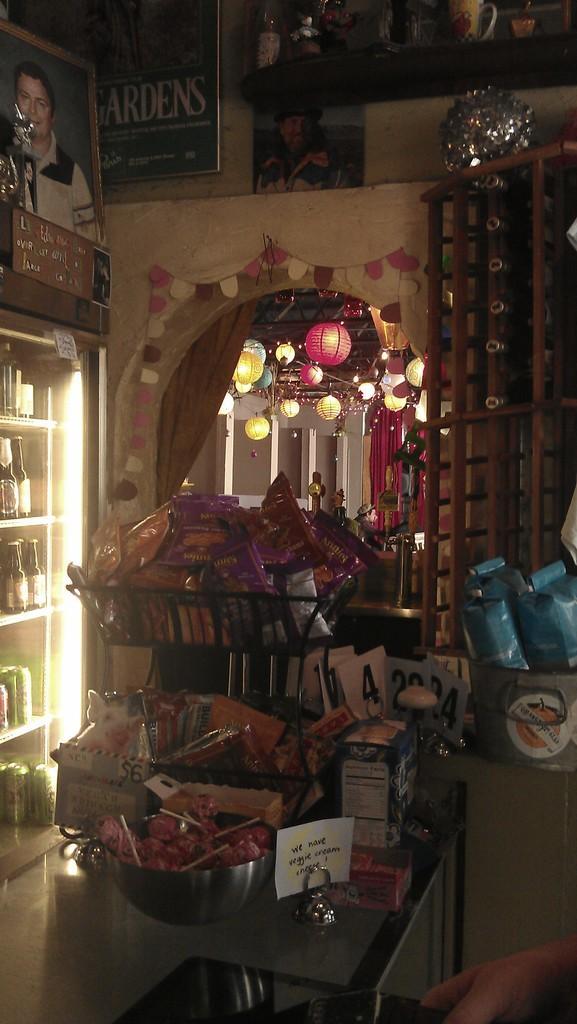Describe this image in one or two sentences. In this picture we can see a bowl, papers and other items on an object and on the left side of the items there are bottles and behind the items there are photos and some decorative items. 